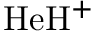Convert formula to latex. <formula><loc_0><loc_0><loc_500><loc_500>H e H ^ { + }</formula> 